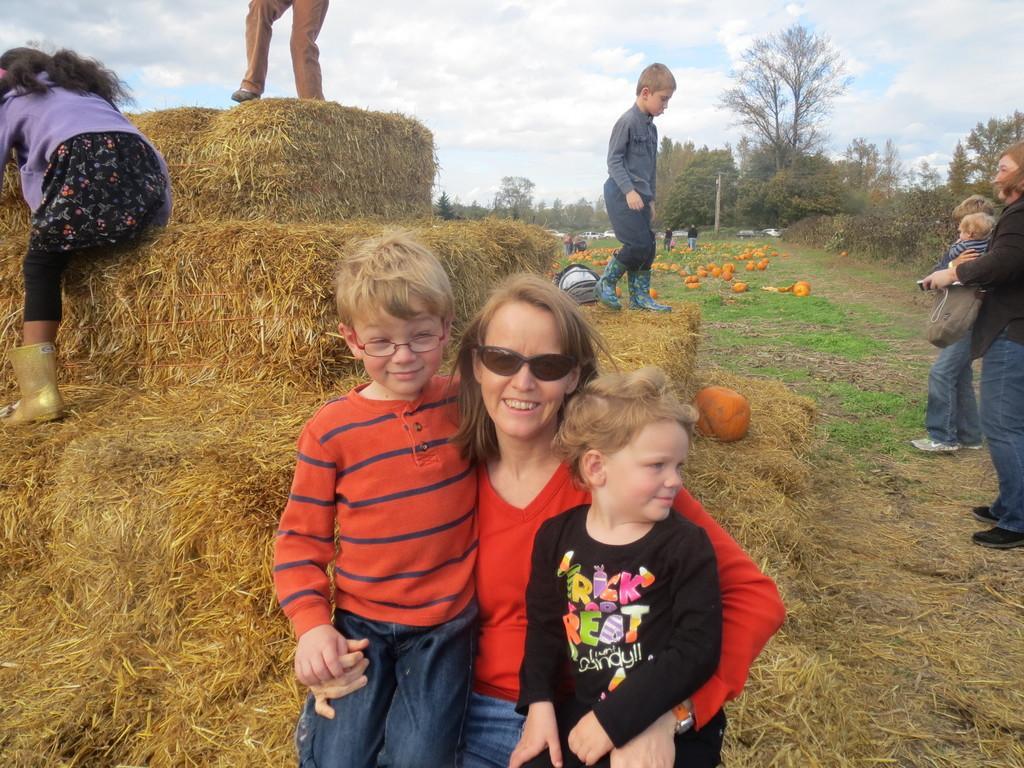Describe this image in one or two sentences. In front of the image there is a woman with two kids, behind them there is dry grass, on the grass there are three kids and a pumpkin, in front of them there are two women holding a kid, in the background of the image there are pumpkins on the grass and there are a few people, cars, trees and electrical poles, at the top of the image there are clouds in the sky. 